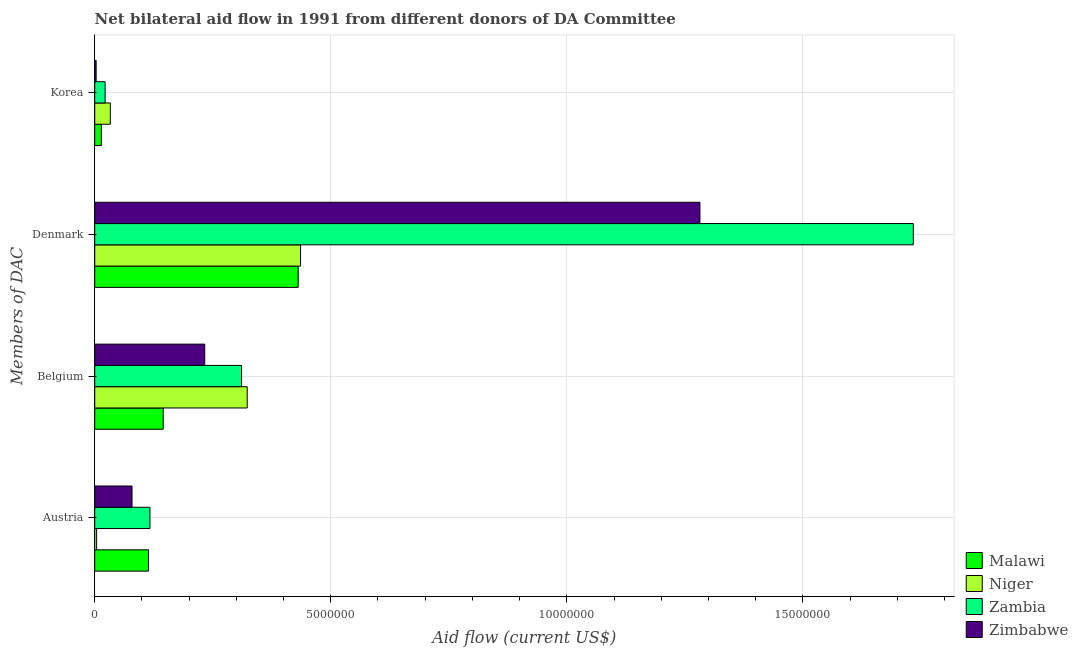How many different coloured bars are there?
Give a very brief answer. 4. How many groups of bars are there?
Offer a terse response. 4. Are the number of bars per tick equal to the number of legend labels?
Offer a terse response. Yes. Are the number of bars on each tick of the Y-axis equal?
Give a very brief answer. Yes. What is the amount of aid given by denmark in Niger?
Your answer should be very brief. 4.36e+06. Across all countries, what is the maximum amount of aid given by denmark?
Your answer should be compact. 1.73e+07. Across all countries, what is the minimum amount of aid given by korea?
Your response must be concise. 3.00e+04. In which country was the amount of aid given by korea maximum?
Provide a short and direct response. Niger. In which country was the amount of aid given by belgium minimum?
Offer a very short reply. Malawi. What is the total amount of aid given by korea in the graph?
Offer a very short reply. 7.20e+05. What is the difference between the amount of aid given by austria in Zimbabwe and that in Niger?
Provide a succinct answer. 7.50e+05. What is the difference between the amount of aid given by korea in Niger and the amount of aid given by belgium in Zimbabwe?
Provide a succinct answer. -2.00e+06. What is the average amount of aid given by austria per country?
Provide a short and direct response. 7.85e+05. What is the difference between the amount of aid given by korea and amount of aid given by denmark in Malawi?
Give a very brief answer. -4.17e+06. What is the ratio of the amount of aid given by austria in Zimbabwe to that in Zambia?
Offer a very short reply. 0.68. Is the amount of aid given by denmark in Zambia less than that in Zimbabwe?
Provide a short and direct response. No. Is the difference between the amount of aid given by austria in Zambia and Zimbabwe greater than the difference between the amount of aid given by belgium in Zambia and Zimbabwe?
Offer a very short reply. No. What is the difference between the highest and the second highest amount of aid given by korea?
Your answer should be compact. 1.10e+05. What is the difference between the highest and the lowest amount of aid given by denmark?
Ensure brevity in your answer.  1.30e+07. Is the sum of the amount of aid given by austria in Malawi and Niger greater than the maximum amount of aid given by denmark across all countries?
Your answer should be very brief. No. Is it the case that in every country, the sum of the amount of aid given by korea and amount of aid given by belgium is greater than the sum of amount of aid given by austria and amount of aid given by denmark?
Provide a short and direct response. No. What does the 2nd bar from the top in Belgium represents?
Keep it short and to the point. Zambia. What does the 2nd bar from the bottom in Belgium represents?
Your response must be concise. Niger. How many bars are there?
Provide a short and direct response. 16. Does the graph contain grids?
Provide a succinct answer. Yes. How are the legend labels stacked?
Ensure brevity in your answer.  Vertical. What is the title of the graph?
Make the answer very short. Net bilateral aid flow in 1991 from different donors of DA Committee. What is the label or title of the X-axis?
Your answer should be very brief. Aid flow (current US$). What is the label or title of the Y-axis?
Your answer should be compact. Members of DAC. What is the Aid flow (current US$) of Malawi in Austria?
Your answer should be very brief. 1.14e+06. What is the Aid flow (current US$) of Zambia in Austria?
Your answer should be very brief. 1.17e+06. What is the Aid flow (current US$) in Zimbabwe in Austria?
Offer a terse response. 7.90e+05. What is the Aid flow (current US$) of Malawi in Belgium?
Your answer should be very brief. 1.45e+06. What is the Aid flow (current US$) in Niger in Belgium?
Make the answer very short. 3.23e+06. What is the Aid flow (current US$) of Zambia in Belgium?
Offer a very short reply. 3.11e+06. What is the Aid flow (current US$) in Zimbabwe in Belgium?
Keep it short and to the point. 2.33e+06. What is the Aid flow (current US$) in Malawi in Denmark?
Give a very brief answer. 4.31e+06. What is the Aid flow (current US$) of Niger in Denmark?
Ensure brevity in your answer.  4.36e+06. What is the Aid flow (current US$) in Zambia in Denmark?
Offer a terse response. 1.73e+07. What is the Aid flow (current US$) of Zimbabwe in Denmark?
Your answer should be very brief. 1.28e+07. What is the Aid flow (current US$) of Niger in Korea?
Keep it short and to the point. 3.30e+05. What is the Aid flow (current US$) in Zambia in Korea?
Offer a terse response. 2.20e+05. Across all Members of DAC, what is the maximum Aid flow (current US$) of Malawi?
Offer a very short reply. 4.31e+06. Across all Members of DAC, what is the maximum Aid flow (current US$) in Niger?
Provide a succinct answer. 4.36e+06. Across all Members of DAC, what is the maximum Aid flow (current US$) of Zambia?
Your answer should be compact. 1.73e+07. Across all Members of DAC, what is the maximum Aid flow (current US$) in Zimbabwe?
Keep it short and to the point. 1.28e+07. Across all Members of DAC, what is the minimum Aid flow (current US$) of Malawi?
Your answer should be compact. 1.40e+05. Across all Members of DAC, what is the minimum Aid flow (current US$) in Niger?
Provide a short and direct response. 4.00e+04. What is the total Aid flow (current US$) of Malawi in the graph?
Offer a very short reply. 7.04e+06. What is the total Aid flow (current US$) in Niger in the graph?
Ensure brevity in your answer.  7.96e+06. What is the total Aid flow (current US$) in Zambia in the graph?
Make the answer very short. 2.18e+07. What is the total Aid flow (current US$) in Zimbabwe in the graph?
Your response must be concise. 1.60e+07. What is the difference between the Aid flow (current US$) of Malawi in Austria and that in Belgium?
Your response must be concise. -3.10e+05. What is the difference between the Aid flow (current US$) in Niger in Austria and that in Belgium?
Provide a short and direct response. -3.19e+06. What is the difference between the Aid flow (current US$) in Zambia in Austria and that in Belgium?
Your answer should be very brief. -1.94e+06. What is the difference between the Aid flow (current US$) of Zimbabwe in Austria and that in Belgium?
Your response must be concise. -1.54e+06. What is the difference between the Aid flow (current US$) in Malawi in Austria and that in Denmark?
Provide a short and direct response. -3.17e+06. What is the difference between the Aid flow (current US$) of Niger in Austria and that in Denmark?
Give a very brief answer. -4.32e+06. What is the difference between the Aid flow (current US$) of Zambia in Austria and that in Denmark?
Your answer should be compact. -1.62e+07. What is the difference between the Aid flow (current US$) in Zimbabwe in Austria and that in Denmark?
Your answer should be very brief. -1.20e+07. What is the difference between the Aid flow (current US$) of Zambia in Austria and that in Korea?
Your answer should be very brief. 9.50e+05. What is the difference between the Aid flow (current US$) of Zimbabwe in Austria and that in Korea?
Provide a succinct answer. 7.60e+05. What is the difference between the Aid flow (current US$) of Malawi in Belgium and that in Denmark?
Ensure brevity in your answer.  -2.86e+06. What is the difference between the Aid flow (current US$) in Niger in Belgium and that in Denmark?
Offer a very short reply. -1.13e+06. What is the difference between the Aid flow (current US$) of Zambia in Belgium and that in Denmark?
Make the answer very short. -1.42e+07. What is the difference between the Aid flow (current US$) in Zimbabwe in Belgium and that in Denmark?
Offer a terse response. -1.05e+07. What is the difference between the Aid flow (current US$) of Malawi in Belgium and that in Korea?
Your answer should be compact. 1.31e+06. What is the difference between the Aid flow (current US$) in Niger in Belgium and that in Korea?
Provide a short and direct response. 2.90e+06. What is the difference between the Aid flow (current US$) of Zambia in Belgium and that in Korea?
Ensure brevity in your answer.  2.89e+06. What is the difference between the Aid flow (current US$) of Zimbabwe in Belgium and that in Korea?
Provide a succinct answer. 2.30e+06. What is the difference between the Aid flow (current US$) of Malawi in Denmark and that in Korea?
Offer a terse response. 4.17e+06. What is the difference between the Aid flow (current US$) of Niger in Denmark and that in Korea?
Offer a terse response. 4.03e+06. What is the difference between the Aid flow (current US$) of Zambia in Denmark and that in Korea?
Your answer should be compact. 1.71e+07. What is the difference between the Aid flow (current US$) of Zimbabwe in Denmark and that in Korea?
Offer a very short reply. 1.28e+07. What is the difference between the Aid flow (current US$) in Malawi in Austria and the Aid flow (current US$) in Niger in Belgium?
Make the answer very short. -2.09e+06. What is the difference between the Aid flow (current US$) in Malawi in Austria and the Aid flow (current US$) in Zambia in Belgium?
Offer a terse response. -1.97e+06. What is the difference between the Aid flow (current US$) of Malawi in Austria and the Aid flow (current US$) of Zimbabwe in Belgium?
Provide a succinct answer. -1.19e+06. What is the difference between the Aid flow (current US$) of Niger in Austria and the Aid flow (current US$) of Zambia in Belgium?
Make the answer very short. -3.07e+06. What is the difference between the Aid flow (current US$) of Niger in Austria and the Aid flow (current US$) of Zimbabwe in Belgium?
Make the answer very short. -2.29e+06. What is the difference between the Aid flow (current US$) of Zambia in Austria and the Aid flow (current US$) of Zimbabwe in Belgium?
Provide a short and direct response. -1.16e+06. What is the difference between the Aid flow (current US$) of Malawi in Austria and the Aid flow (current US$) of Niger in Denmark?
Provide a short and direct response. -3.22e+06. What is the difference between the Aid flow (current US$) in Malawi in Austria and the Aid flow (current US$) in Zambia in Denmark?
Ensure brevity in your answer.  -1.62e+07. What is the difference between the Aid flow (current US$) in Malawi in Austria and the Aid flow (current US$) in Zimbabwe in Denmark?
Give a very brief answer. -1.17e+07. What is the difference between the Aid flow (current US$) of Niger in Austria and the Aid flow (current US$) of Zambia in Denmark?
Your answer should be compact. -1.73e+07. What is the difference between the Aid flow (current US$) of Niger in Austria and the Aid flow (current US$) of Zimbabwe in Denmark?
Offer a very short reply. -1.28e+07. What is the difference between the Aid flow (current US$) in Zambia in Austria and the Aid flow (current US$) in Zimbabwe in Denmark?
Offer a very short reply. -1.16e+07. What is the difference between the Aid flow (current US$) of Malawi in Austria and the Aid flow (current US$) of Niger in Korea?
Offer a very short reply. 8.10e+05. What is the difference between the Aid flow (current US$) in Malawi in Austria and the Aid flow (current US$) in Zambia in Korea?
Provide a short and direct response. 9.20e+05. What is the difference between the Aid flow (current US$) in Malawi in Austria and the Aid flow (current US$) in Zimbabwe in Korea?
Make the answer very short. 1.11e+06. What is the difference between the Aid flow (current US$) of Niger in Austria and the Aid flow (current US$) of Zimbabwe in Korea?
Give a very brief answer. 10000. What is the difference between the Aid flow (current US$) of Zambia in Austria and the Aid flow (current US$) of Zimbabwe in Korea?
Keep it short and to the point. 1.14e+06. What is the difference between the Aid flow (current US$) in Malawi in Belgium and the Aid flow (current US$) in Niger in Denmark?
Ensure brevity in your answer.  -2.91e+06. What is the difference between the Aid flow (current US$) in Malawi in Belgium and the Aid flow (current US$) in Zambia in Denmark?
Your answer should be compact. -1.59e+07. What is the difference between the Aid flow (current US$) in Malawi in Belgium and the Aid flow (current US$) in Zimbabwe in Denmark?
Give a very brief answer. -1.14e+07. What is the difference between the Aid flow (current US$) of Niger in Belgium and the Aid flow (current US$) of Zambia in Denmark?
Your answer should be compact. -1.41e+07. What is the difference between the Aid flow (current US$) of Niger in Belgium and the Aid flow (current US$) of Zimbabwe in Denmark?
Offer a very short reply. -9.59e+06. What is the difference between the Aid flow (current US$) of Zambia in Belgium and the Aid flow (current US$) of Zimbabwe in Denmark?
Ensure brevity in your answer.  -9.71e+06. What is the difference between the Aid flow (current US$) in Malawi in Belgium and the Aid flow (current US$) in Niger in Korea?
Your answer should be compact. 1.12e+06. What is the difference between the Aid flow (current US$) of Malawi in Belgium and the Aid flow (current US$) of Zambia in Korea?
Your response must be concise. 1.23e+06. What is the difference between the Aid flow (current US$) in Malawi in Belgium and the Aid flow (current US$) in Zimbabwe in Korea?
Offer a very short reply. 1.42e+06. What is the difference between the Aid flow (current US$) in Niger in Belgium and the Aid flow (current US$) in Zambia in Korea?
Provide a succinct answer. 3.01e+06. What is the difference between the Aid flow (current US$) of Niger in Belgium and the Aid flow (current US$) of Zimbabwe in Korea?
Provide a short and direct response. 3.20e+06. What is the difference between the Aid flow (current US$) in Zambia in Belgium and the Aid flow (current US$) in Zimbabwe in Korea?
Give a very brief answer. 3.08e+06. What is the difference between the Aid flow (current US$) of Malawi in Denmark and the Aid flow (current US$) of Niger in Korea?
Offer a terse response. 3.98e+06. What is the difference between the Aid flow (current US$) of Malawi in Denmark and the Aid flow (current US$) of Zambia in Korea?
Give a very brief answer. 4.09e+06. What is the difference between the Aid flow (current US$) of Malawi in Denmark and the Aid flow (current US$) of Zimbabwe in Korea?
Your response must be concise. 4.28e+06. What is the difference between the Aid flow (current US$) of Niger in Denmark and the Aid flow (current US$) of Zambia in Korea?
Your answer should be very brief. 4.14e+06. What is the difference between the Aid flow (current US$) of Niger in Denmark and the Aid flow (current US$) of Zimbabwe in Korea?
Give a very brief answer. 4.33e+06. What is the difference between the Aid flow (current US$) of Zambia in Denmark and the Aid flow (current US$) of Zimbabwe in Korea?
Provide a succinct answer. 1.73e+07. What is the average Aid flow (current US$) in Malawi per Members of DAC?
Your answer should be very brief. 1.76e+06. What is the average Aid flow (current US$) in Niger per Members of DAC?
Offer a terse response. 1.99e+06. What is the average Aid flow (current US$) in Zambia per Members of DAC?
Your response must be concise. 5.46e+06. What is the average Aid flow (current US$) of Zimbabwe per Members of DAC?
Give a very brief answer. 3.99e+06. What is the difference between the Aid flow (current US$) of Malawi and Aid flow (current US$) of Niger in Austria?
Give a very brief answer. 1.10e+06. What is the difference between the Aid flow (current US$) in Malawi and Aid flow (current US$) in Zimbabwe in Austria?
Your answer should be very brief. 3.50e+05. What is the difference between the Aid flow (current US$) of Niger and Aid flow (current US$) of Zambia in Austria?
Ensure brevity in your answer.  -1.13e+06. What is the difference between the Aid flow (current US$) of Niger and Aid flow (current US$) of Zimbabwe in Austria?
Make the answer very short. -7.50e+05. What is the difference between the Aid flow (current US$) of Zambia and Aid flow (current US$) of Zimbabwe in Austria?
Offer a terse response. 3.80e+05. What is the difference between the Aid flow (current US$) in Malawi and Aid flow (current US$) in Niger in Belgium?
Provide a succinct answer. -1.78e+06. What is the difference between the Aid flow (current US$) of Malawi and Aid flow (current US$) of Zambia in Belgium?
Provide a succinct answer. -1.66e+06. What is the difference between the Aid flow (current US$) in Malawi and Aid flow (current US$) in Zimbabwe in Belgium?
Offer a very short reply. -8.80e+05. What is the difference between the Aid flow (current US$) in Niger and Aid flow (current US$) in Zambia in Belgium?
Your response must be concise. 1.20e+05. What is the difference between the Aid flow (current US$) in Niger and Aid flow (current US$) in Zimbabwe in Belgium?
Provide a short and direct response. 9.00e+05. What is the difference between the Aid flow (current US$) in Zambia and Aid flow (current US$) in Zimbabwe in Belgium?
Offer a very short reply. 7.80e+05. What is the difference between the Aid flow (current US$) of Malawi and Aid flow (current US$) of Zambia in Denmark?
Provide a short and direct response. -1.30e+07. What is the difference between the Aid flow (current US$) of Malawi and Aid flow (current US$) of Zimbabwe in Denmark?
Offer a terse response. -8.51e+06. What is the difference between the Aid flow (current US$) of Niger and Aid flow (current US$) of Zambia in Denmark?
Your answer should be very brief. -1.30e+07. What is the difference between the Aid flow (current US$) in Niger and Aid flow (current US$) in Zimbabwe in Denmark?
Make the answer very short. -8.46e+06. What is the difference between the Aid flow (current US$) in Zambia and Aid flow (current US$) in Zimbabwe in Denmark?
Make the answer very short. 4.52e+06. What is the difference between the Aid flow (current US$) in Malawi and Aid flow (current US$) in Niger in Korea?
Provide a succinct answer. -1.90e+05. What is the difference between the Aid flow (current US$) of Malawi and Aid flow (current US$) of Zambia in Korea?
Offer a terse response. -8.00e+04. What is the difference between the Aid flow (current US$) of Malawi and Aid flow (current US$) of Zimbabwe in Korea?
Your answer should be very brief. 1.10e+05. What is the difference between the Aid flow (current US$) in Niger and Aid flow (current US$) in Zambia in Korea?
Your answer should be very brief. 1.10e+05. What is the difference between the Aid flow (current US$) of Zambia and Aid flow (current US$) of Zimbabwe in Korea?
Keep it short and to the point. 1.90e+05. What is the ratio of the Aid flow (current US$) of Malawi in Austria to that in Belgium?
Provide a succinct answer. 0.79. What is the ratio of the Aid flow (current US$) of Niger in Austria to that in Belgium?
Provide a succinct answer. 0.01. What is the ratio of the Aid flow (current US$) in Zambia in Austria to that in Belgium?
Give a very brief answer. 0.38. What is the ratio of the Aid flow (current US$) of Zimbabwe in Austria to that in Belgium?
Provide a succinct answer. 0.34. What is the ratio of the Aid flow (current US$) of Malawi in Austria to that in Denmark?
Your answer should be compact. 0.26. What is the ratio of the Aid flow (current US$) in Niger in Austria to that in Denmark?
Your response must be concise. 0.01. What is the ratio of the Aid flow (current US$) in Zambia in Austria to that in Denmark?
Provide a succinct answer. 0.07. What is the ratio of the Aid flow (current US$) in Zimbabwe in Austria to that in Denmark?
Ensure brevity in your answer.  0.06. What is the ratio of the Aid flow (current US$) of Malawi in Austria to that in Korea?
Offer a terse response. 8.14. What is the ratio of the Aid flow (current US$) in Niger in Austria to that in Korea?
Give a very brief answer. 0.12. What is the ratio of the Aid flow (current US$) of Zambia in Austria to that in Korea?
Your answer should be very brief. 5.32. What is the ratio of the Aid flow (current US$) of Zimbabwe in Austria to that in Korea?
Offer a terse response. 26.33. What is the ratio of the Aid flow (current US$) of Malawi in Belgium to that in Denmark?
Your response must be concise. 0.34. What is the ratio of the Aid flow (current US$) in Niger in Belgium to that in Denmark?
Your response must be concise. 0.74. What is the ratio of the Aid flow (current US$) in Zambia in Belgium to that in Denmark?
Provide a succinct answer. 0.18. What is the ratio of the Aid flow (current US$) of Zimbabwe in Belgium to that in Denmark?
Make the answer very short. 0.18. What is the ratio of the Aid flow (current US$) of Malawi in Belgium to that in Korea?
Keep it short and to the point. 10.36. What is the ratio of the Aid flow (current US$) in Niger in Belgium to that in Korea?
Provide a short and direct response. 9.79. What is the ratio of the Aid flow (current US$) of Zambia in Belgium to that in Korea?
Keep it short and to the point. 14.14. What is the ratio of the Aid flow (current US$) in Zimbabwe in Belgium to that in Korea?
Provide a short and direct response. 77.67. What is the ratio of the Aid flow (current US$) in Malawi in Denmark to that in Korea?
Provide a succinct answer. 30.79. What is the ratio of the Aid flow (current US$) in Niger in Denmark to that in Korea?
Ensure brevity in your answer.  13.21. What is the ratio of the Aid flow (current US$) of Zambia in Denmark to that in Korea?
Ensure brevity in your answer.  78.82. What is the ratio of the Aid flow (current US$) of Zimbabwe in Denmark to that in Korea?
Keep it short and to the point. 427.33. What is the difference between the highest and the second highest Aid flow (current US$) in Malawi?
Your answer should be very brief. 2.86e+06. What is the difference between the highest and the second highest Aid flow (current US$) of Niger?
Provide a short and direct response. 1.13e+06. What is the difference between the highest and the second highest Aid flow (current US$) of Zambia?
Ensure brevity in your answer.  1.42e+07. What is the difference between the highest and the second highest Aid flow (current US$) in Zimbabwe?
Make the answer very short. 1.05e+07. What is the difference between the highest and the lowest Aid flow (current US$) in Malawi?
Give a very brief answer. 4.17e+06. What is the difference between the highest and the lowest Aid flow (current US$) of Niger?
Provide a succinct answer. 4.32e+06. What is the difference between the highest and the lowest Aid flow (current US$) in Zambia?
Your answer should be very brief. 1.71e+07. What is the difference between the highest and the lowest Aid flow (current US$) in Zimbabwe?
Make the answer very short. 1.28e+07. 